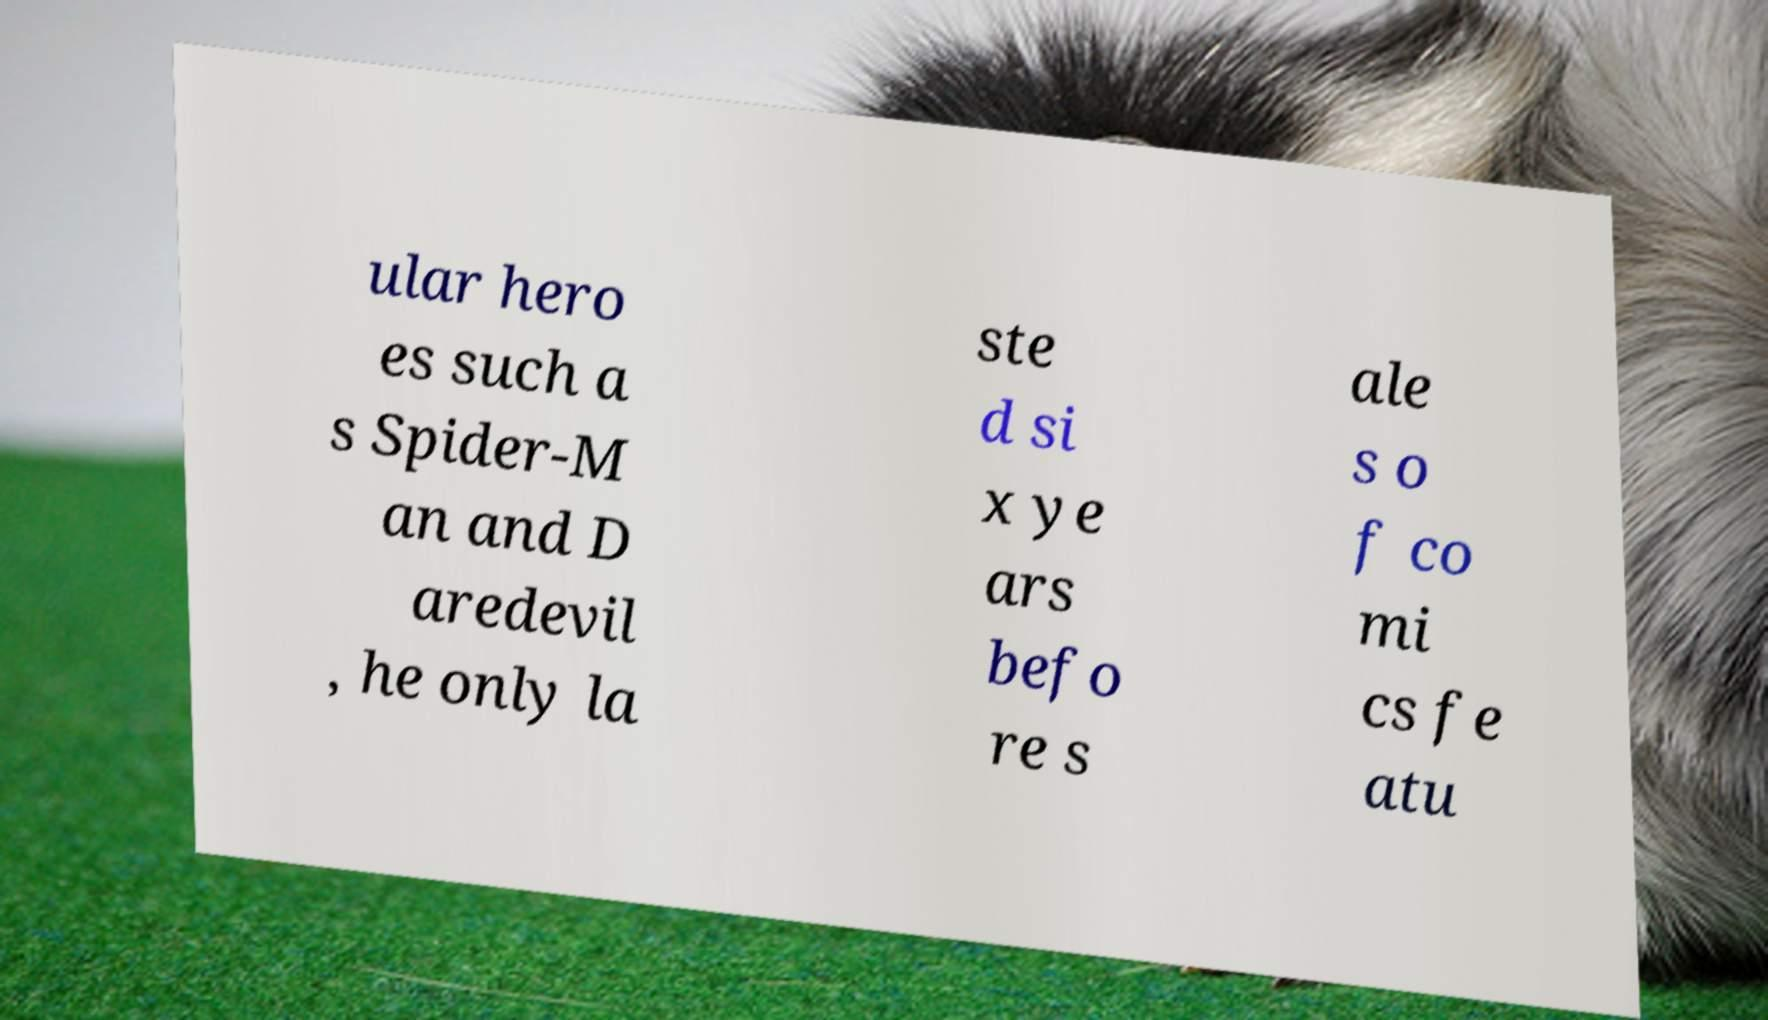Please identify and transcribe the text found in this image. ular hero es such a s Spider-M an and D aredevil , he only la ste d si x ye ars befo re s ale s o f co mi cs fe atu 